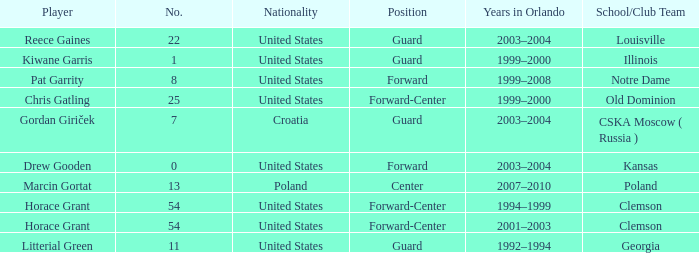What number identifies Chris Gatling? 25.0. 